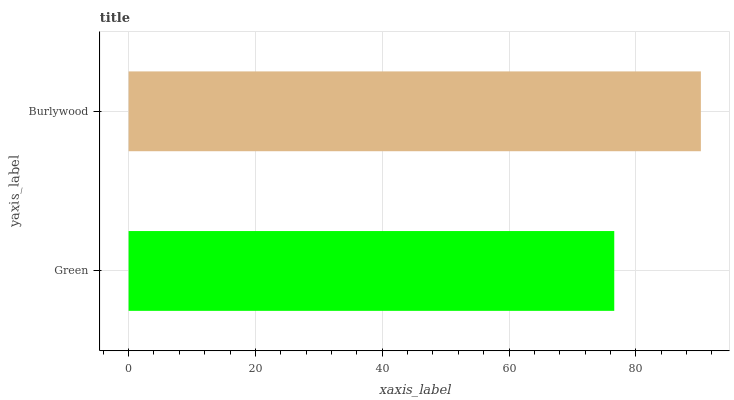Is Green the minimum?
Answer yes or no. Yes. Is Burlywood the maximum?
Answer yes or no. Yes. Is Burlywood the minimum?
Answer yes or no. No. Is Burlywood greater than Green?
Answer yes or no. Yes. Is Green less than Burlywood?
Answer yes or no. Yes. Is Green greater than Burlywood?
Answer yes or no. No. Is Burlywood less than Green?
Answer yes or no. No. Is Burlywood the high median?
Answer yes or no. Yes. Is Green the low median?
Answer yes or no. Yes. Is Green the high median?
Answer yes or no. No. Is Burlywood the low median?
Answer yes or no. No. 